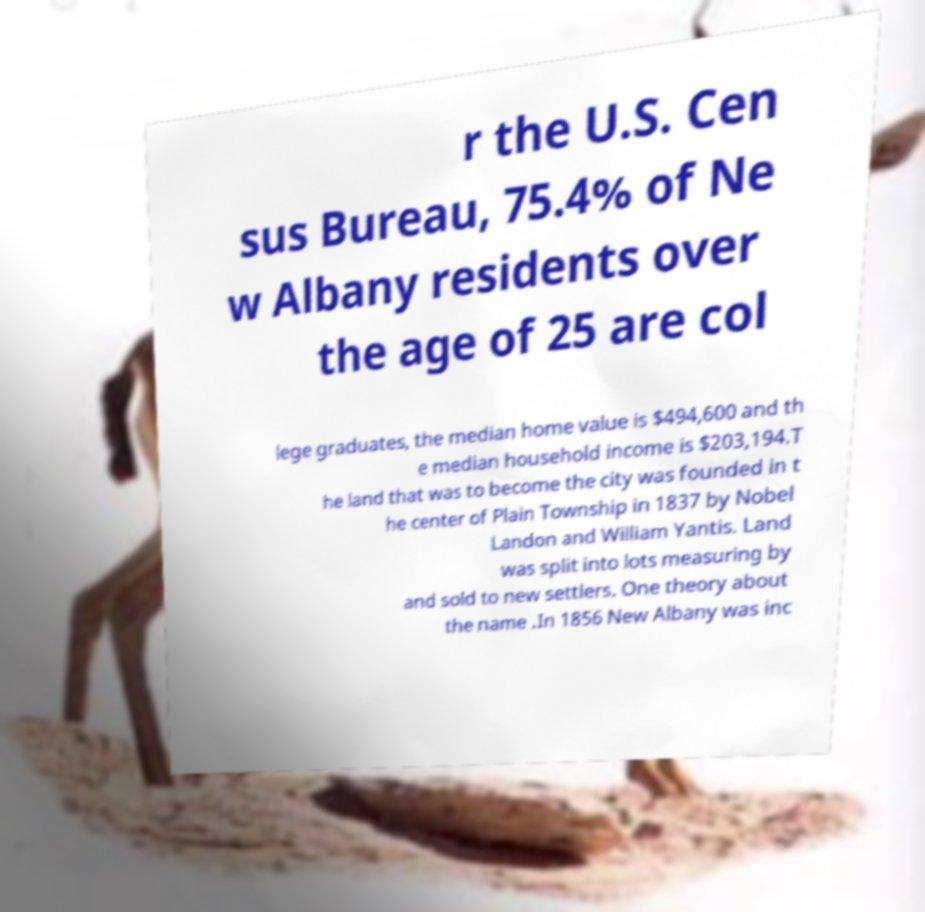Could you assist in decoding the text presented in this image and type it out clearly? r the U.S. Cen sus Bureau, 75.4% of Ne w Albany residents over the age of 25 are col lege graduates, the median home value is $494,600 and th e median household income is $203,194.T he land that was to become the city was founded in t he center of Plain Township in 1837 by Nobel Landon and William Yantis. Land was split into lots measuring by and sold to new settlers. One theory about the name .In 1856 New Albany was inc 